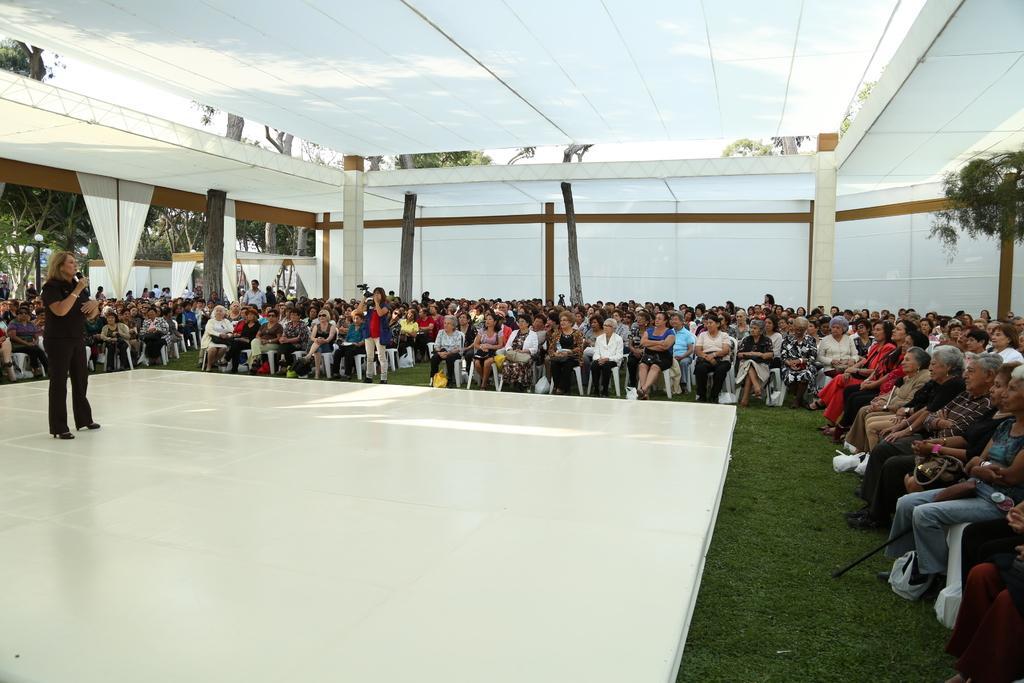Please provide a concise description of this image. In this picture we can see a woman standing and holding a mike, there is a stage here, we can see some people sitting on chairs and looking at this woman, at the bottom there is grass, we can see some pillars here, in the background there are some trees, we can see cloth here. 